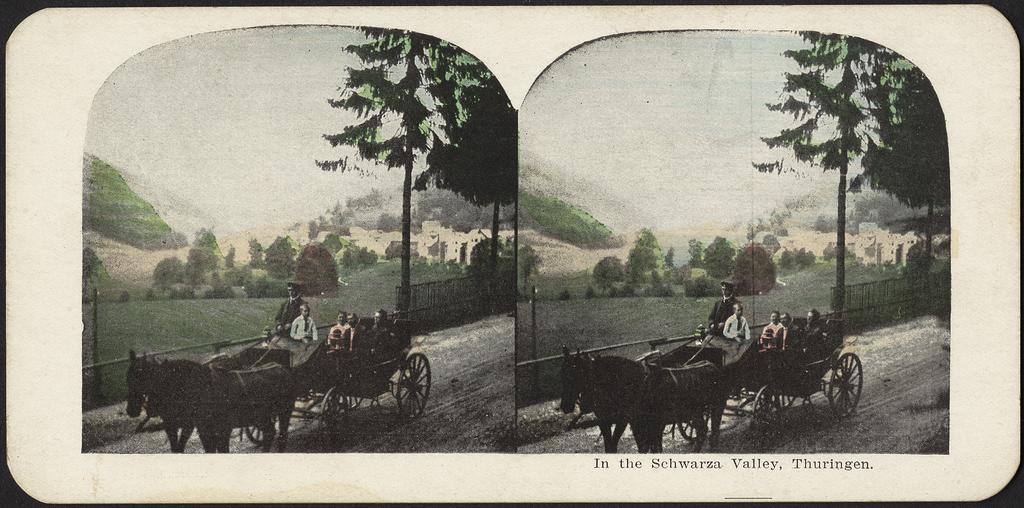Could you give a brief overview of what you see in this image? It is the collage of two pictures in which there is a horse cart in the middle. In the horse cart there are few people sitting in it. In the background there are trees and hills. 